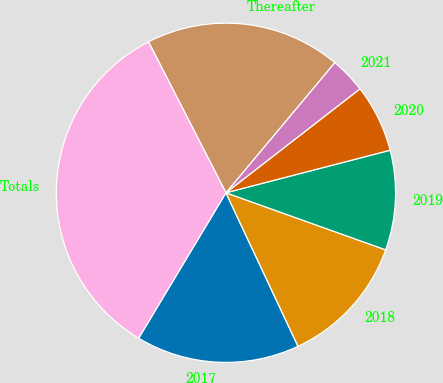Convert chart. <chart><loc_0><loc_0><loc_500><loc_500><pie_chart><fcel>2017<fcel>2018<fcel>2019<fcel>2020<fcel>2021<fcel>Thereafter<fcel>Totals<nl><fcel>15.59%<fcel>12.55%<fcel>9.5%<fcel>6.46%<fcel>3.42%<fcel>18.63%<fcel>33.85%<nl></chart> 